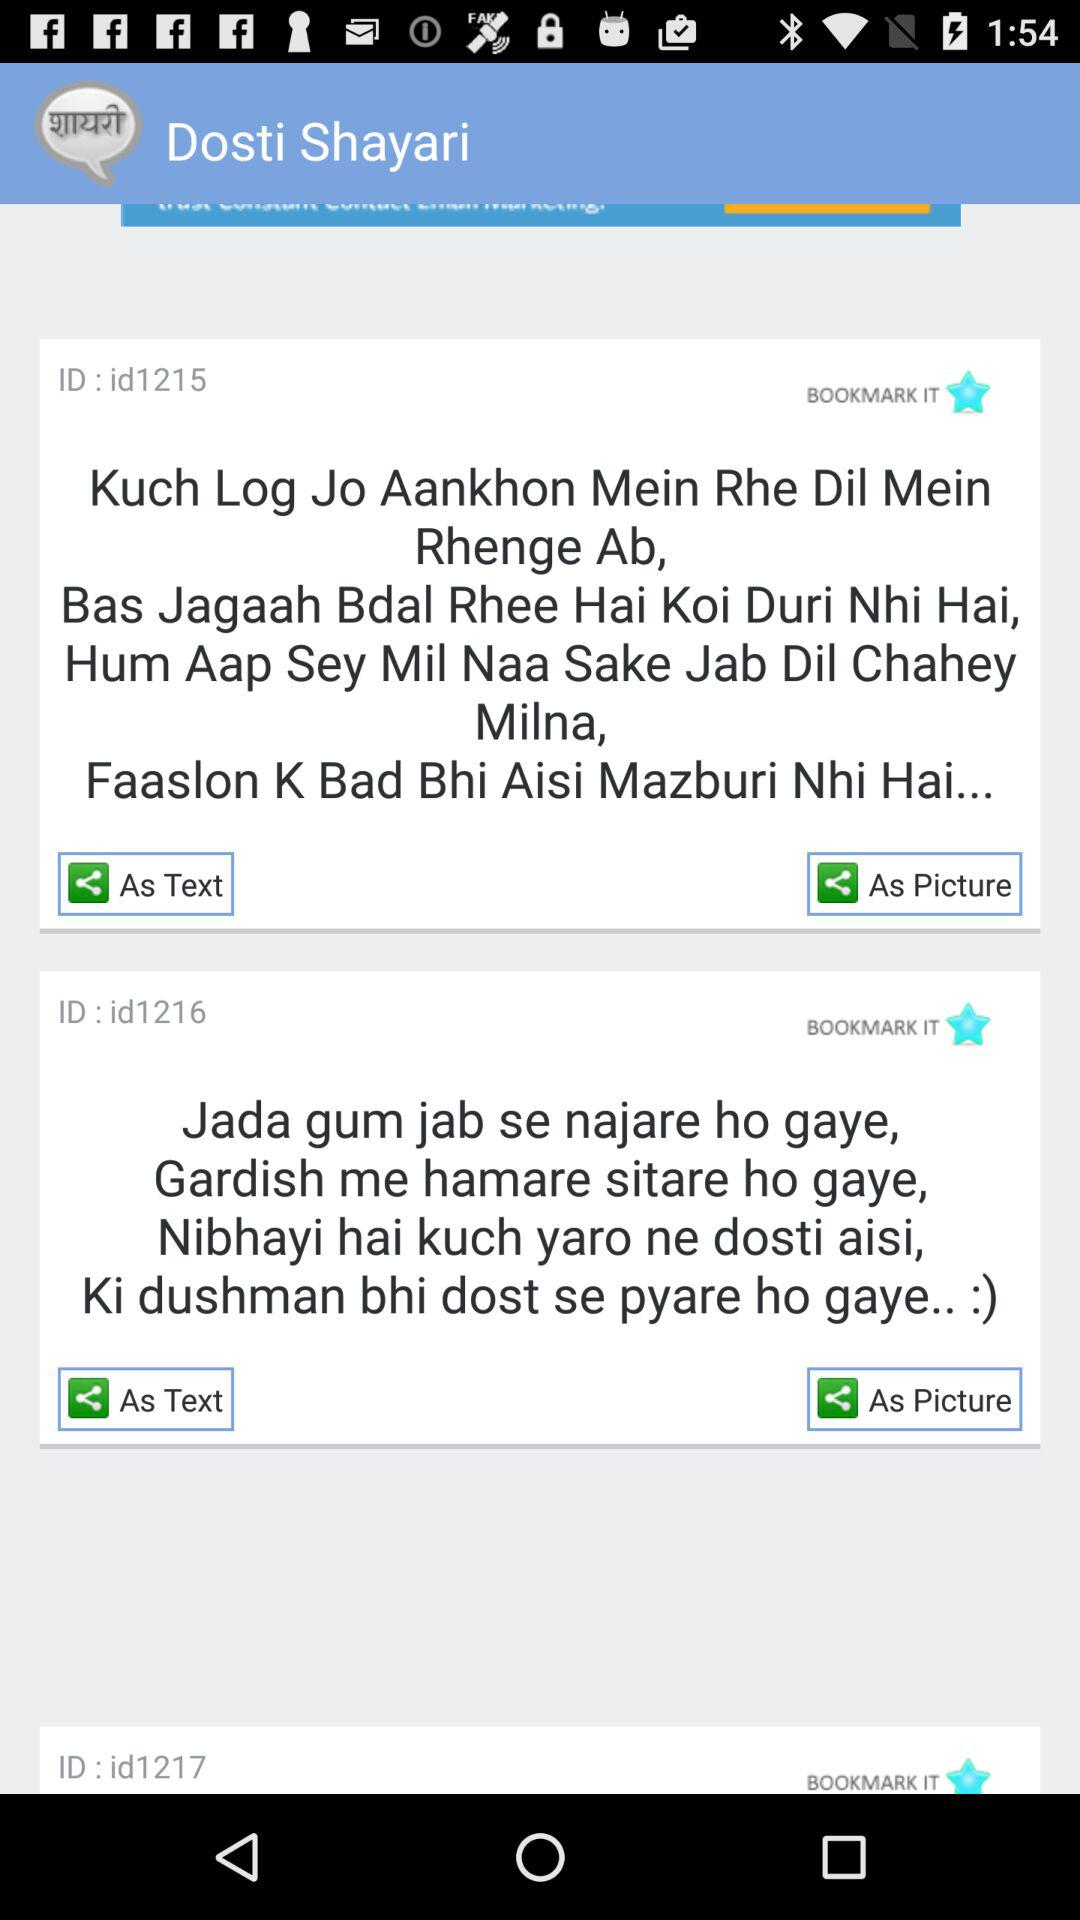What is the application name? The application name is "Dosti Shayari". 